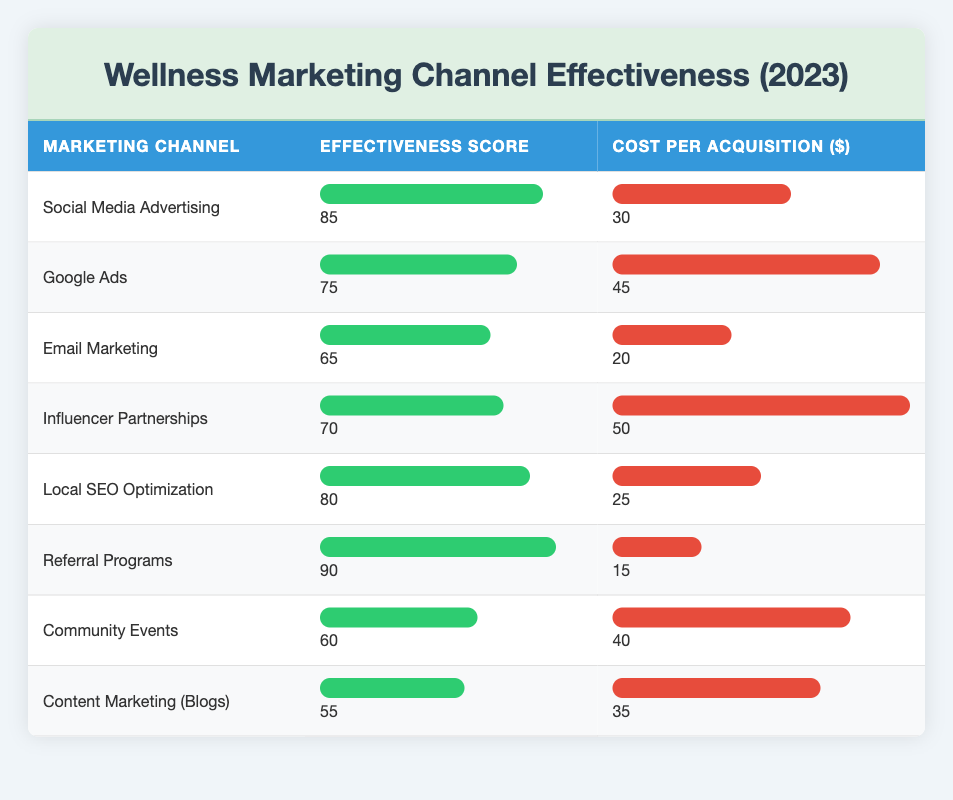What is the effectiveness score of Social Media Advertising? The table lists the effectiveness score for Social Media Advertising directly in the corresponding row. The score is 85.
Answer: 85 Which marketing channel has the highest cost per acquisition? By comparing the cost per acquisition values for each channel in the table, Influencer Partnerships has the highest value at 50.
Answer: 50 Is Email Marketing more effective than Community Events? The effectiveness scores show Email Marketing has a score of 65 while Community Events has a score of 60. Since 65 is greater than 60, Email Marketing is indeed more effective.
Answer: Yes What is the average cost per acquisition for the top three effective marketing channels? The top three effective channels based on the effectiveness score are Referral Programs (15), Social Media Advertising (30), and Local SEO Optimization (25). The total cost is 15 + 30 + 25 = 70, divided by 3 gives an average of 70/3 ≈ 23.33.
Answer: Approximately 23.33 Which marketing channel provides the lowest cost per acquisition and what is that cost? Referring to the cost per acquisition values, Referral Programs has the lowest cost at 15 among all channels.
Answer: 15 If you were to order the channels by effectiveness score, which would be the second highest? Sorting the effectiveness scores, the channel with the second highest score is Social Media Advertising with a score of 85, following Referral Programs which has 90.
Answer: Social Media Advertising Is it true that Local SEO Optimization has a better effectiveness score than Google Ads? Comparing the effectiveness scores, Local SEO Optimization has a score of 80 while Google Ads has a score of 75. Since 80 is greater than 75, the statement is true.
Answer: Yes What is the difference in effectiveness scores between the most and least effective marketing channels? The most effective channel is Referral Programs (effectiveness score of 90) and the least effective is Content Marketing (Blogs) (effectiveness score of 55). The difference is 90 - 55 = 35.
Answer: 35 